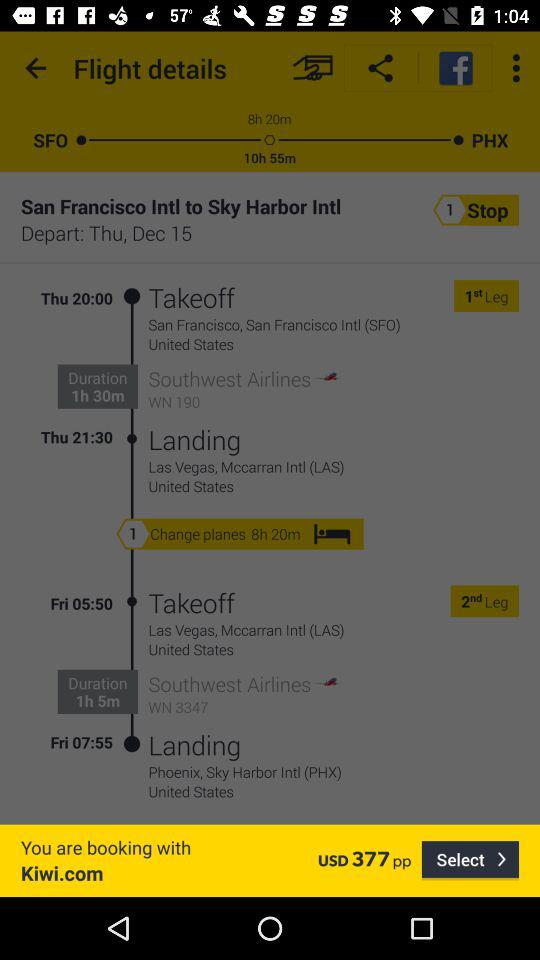What is the time interval between two journeys? The time interval is 8 hours and 20 minutes. 